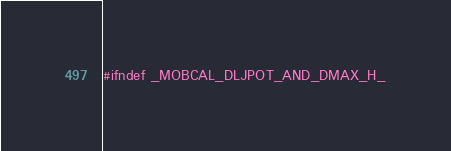Convert code to text. <code><loc_0><loc_0><loc_500><loc_500><_C_>#ifndef _MOBCAL_DLJPOT_AND_DMAX_H_</code> 